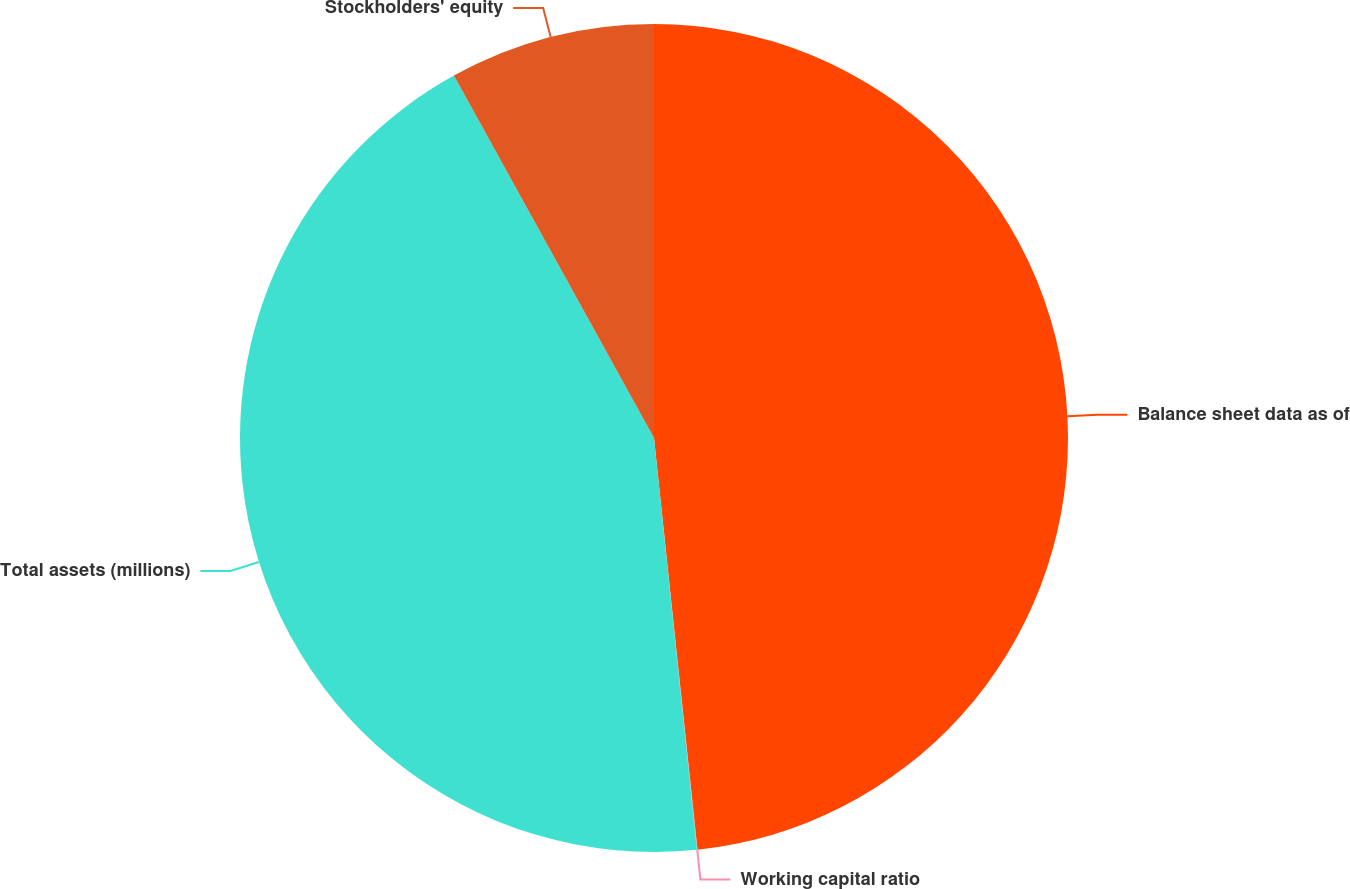Convert chart. <chart><loc_0><loc_0><loc_500><loc_500><pie_chart><fcel>Balance sheet data as of<fcel>Working capital ratio<fcel>Total assets (millions)<fcel>Stockholders' equity<nl><fcel>48.32%<fcel>0.02%<fcel>43.62%<fcel>8.03%<nl></chart> 